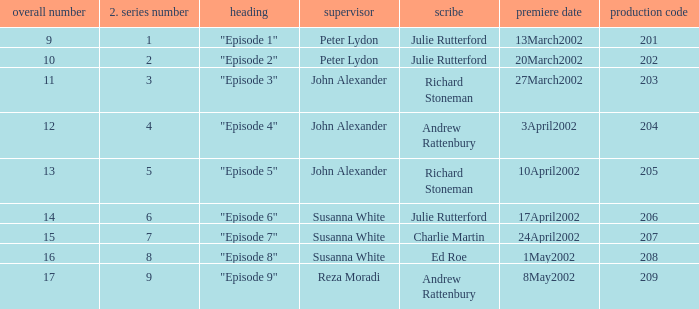When 1 is the number in series who is the director? Peter Lydon. Give me the full table as a dictionary. {'header': ['overall number', '2. series number', 'heading', 'supervisor', 'scribe', 'premiere date', 'production code'], 'rows': [['9', '1', '"Episode 1"', 'Peter Lydon', 'Julie Rutterford', '13March2002', '201'], ['10', '2', '"Episode 2"', 'Peter Lydon', 'Julie Rutterford', '20March2002', '202'], ['11', '3', '"Episode 3"', 'John Alexander', 'Richard Stoneman', '27March2002', '203'], ['12', '4', '"Episode 4"', 'John Alexander', 'Andrew Rattenbury', '3April2002', '204'], ['13', '5', '"Episode 5"', 'John Alexander', 'Richard Stoneman', '10April2002', '205'], ['14', '6', '"Episode 6"', 'Susanna White', 'Julie Rutterford', '17April2002', '206'], ['15', '7', '"Episode 7"', 'Susanna White', 'Charlie Martin', '24April2002', '207'], ['16', '8', '"Episode 8"', 'Susanna White', 'Ed Roe', '1May2002', '208'], ['17', '9', '"Episode 9"', 'Reza Moradi', 'Andrew Rattenbury', '8May2002', '209']]} 